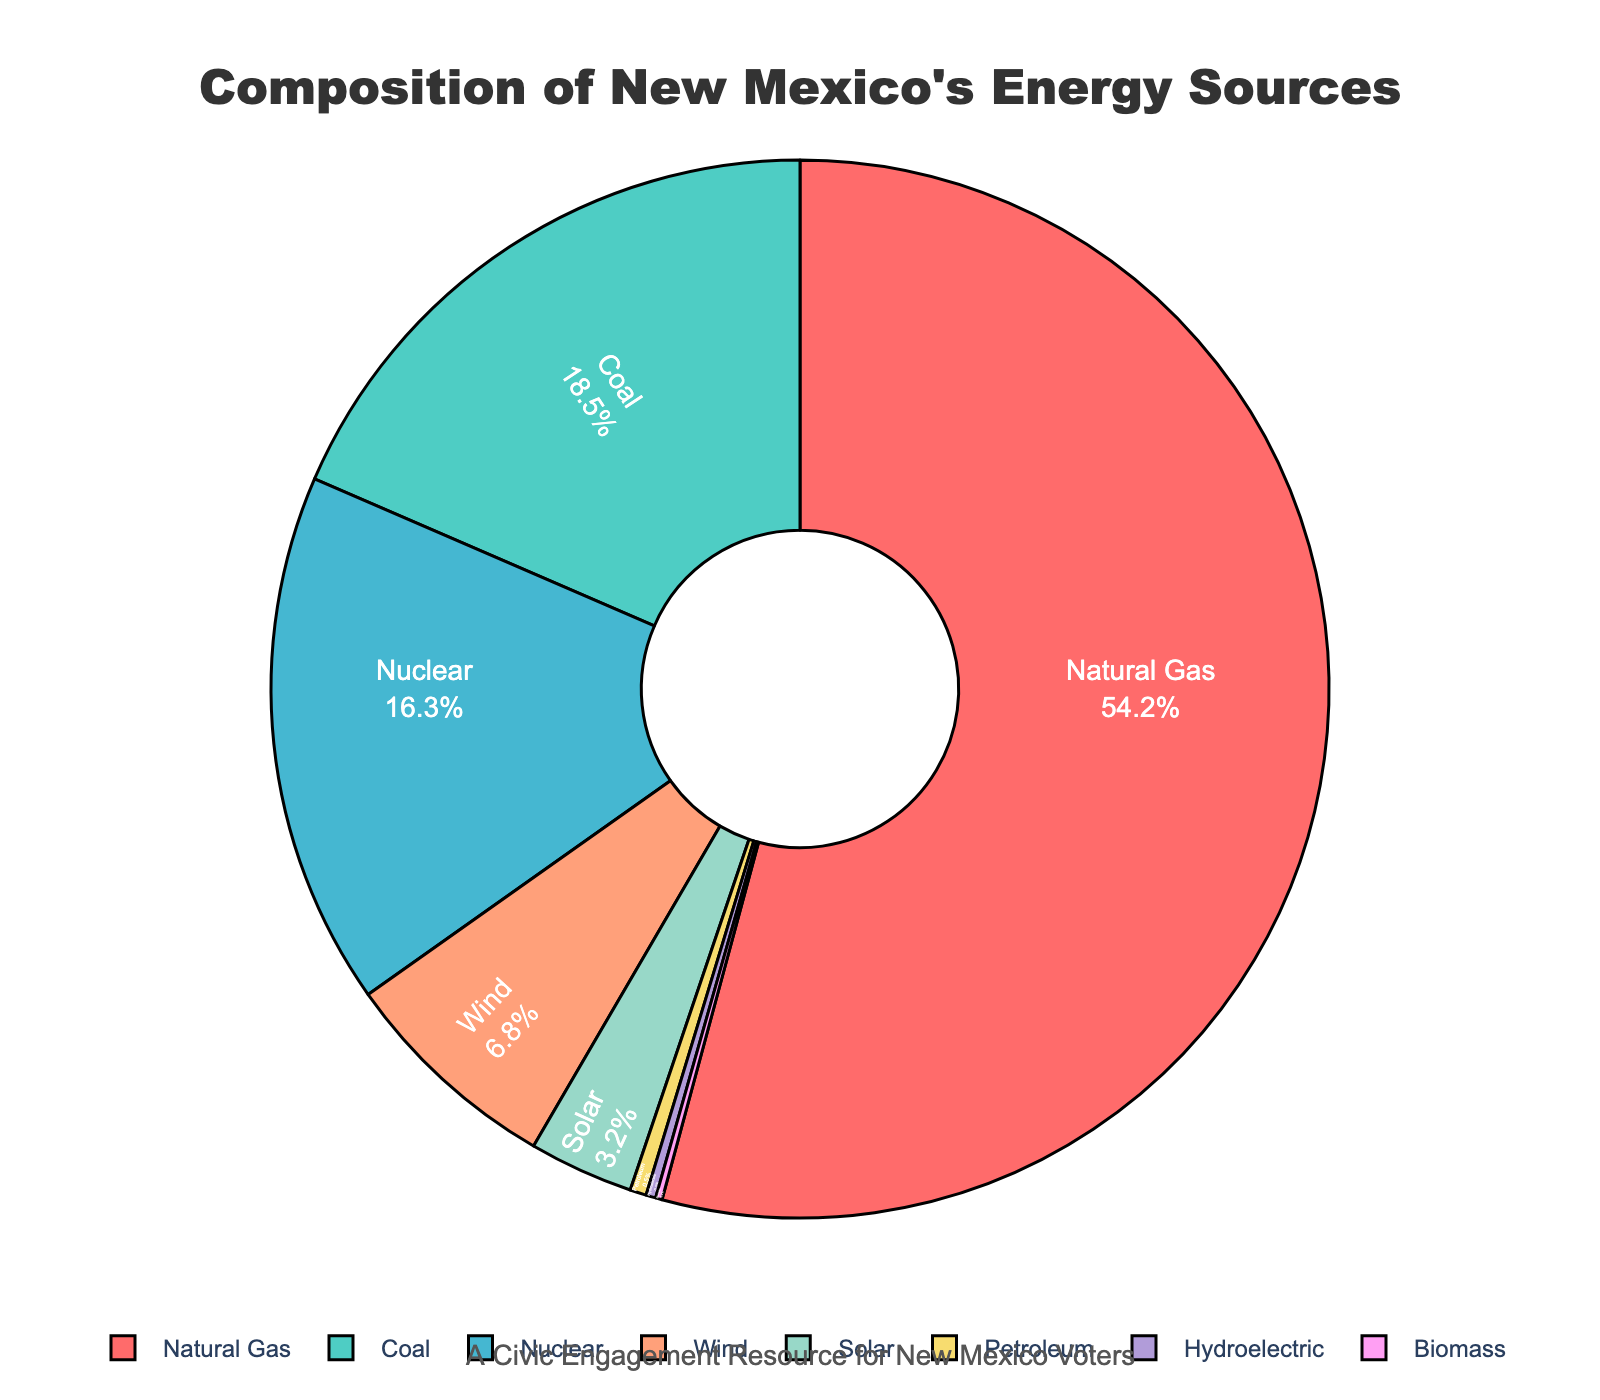What is the largest energy source in New Mexico? The slice labeled "Natural Gas" occupies the largest portion of the pie chart, accounting for 54.2% of the total energy sources.
Answer: Natural Gas How much more energy comes from Natural Gas than Wind? Natural Gas accounts for 54.2% and Wind accounts for 6.8%. The difference is calculated as 54.2% - 6.8% = 47.4%.
Answer: 47.4% Which two energy sources combined make up approximately one-third of the energy composition? Coal represents 18.5% and Nuclear represents 16.3%. Summing these percentages gives 18.5% + 16.3% = 34.8%, which is close to one-third.
Answer: Coal and Nuclear What is the combined percentage of Solar, Wind, and Biomass energy sources? Solar is 3.2%, Wind is 6.8%, and Biomass is 0.2%. Adding these gives 3.2% + 6.8% + 0.2% = 10.2%.
Answer: 10.2% Which energy source contributes the least to New Mexico's energy production? From the pie chart data, Biomass contributes 0.2%, which is the smallest percentage.
Answer: Biomass Compare the percentages of Nuclear and Coal energy sources. Which one is greater and by how much? Nuclear is at 16.3% and Coal is at 18.5%. Coal is greater. The difference is 18.5% - 16.3% = 2.2%.
Answer: Coal by 2.2% What percentage of New Mexico's energy comes from renewable sources (Wind, Solar, Hydroelectric, Biomass)? Wind is 6.8%, Solar is 3.2%, Hydroelectric is 0.3%, and Biomass is 0.2%. Summing these gives 6.8% + 3.2% + 0.3% + 0.2% = 10.5%.
Answer: 10.5% If the total energy production were to be doubled, what percentage of the new total would be from Nuclear energy? Doubling the total energy production doesn't change the proportion of each source. Nuclear energy would still be 16.3% of the new total.
Answer: 16.3% Among Natural Gas, Coal, and Nuclear energy sources, which one has the smallest percentage and what is that percentage? Natural Gas is 54.2%, Coal is 18.5%, and Nuclear is 16.3%. Nuclear has the smallest percentage among the three.
Answer: Nuclear 16.3% What is the difference in percentage between the largest and smallest renewable energy sources? Wind (largest renewable) is 6.8% and Biomass (smallest renewable) is 0.2%. The difference is 6.8% - 0.2% = 6.6%.
Answer: 6.6% 